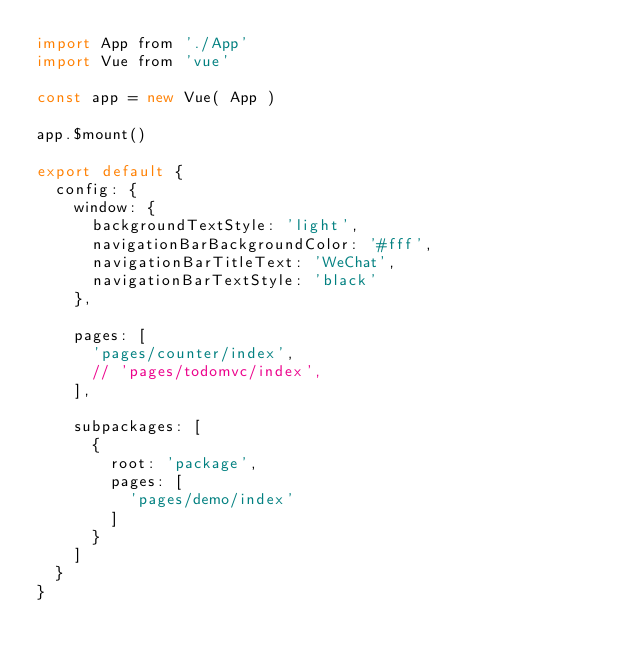Convert code to text. <code><loc_0><loc_0><loc_500><loc_500><_JavaScript_>import App from './App'
import Vue from 'vue'

const app = new Vue( App )

app.$mount()

export default {
  config: {
    window: {
      backgroundTextStyle: 'light',
      navigationBarBackgroundColor: '#fff',
      navigationBarTitleText: 'WeChat',
      navigationBarTextStyle: 'black'
    },

    pages: [
      'pages/counter/index',
      // 'pages/todomvc/index',
    ],

    subpackages: [
      {
        root: 'package',
        pages: [
          'pages/demo/index'
        ]
      }
    ]
  }
}
</code> 